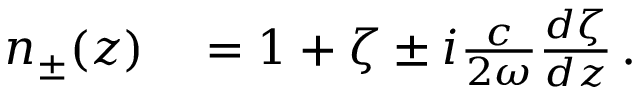Convert formula to latex. <formula><loc_0><loc_0><loc_500><loc_500>\begin{array} { r l } { n _ { \pm } ( z ) } & = 1 + \zeta \pm i \frac { c } { 2 \omega } \frac { d \zeta } { d z } \, . } \end{array}</formula> 